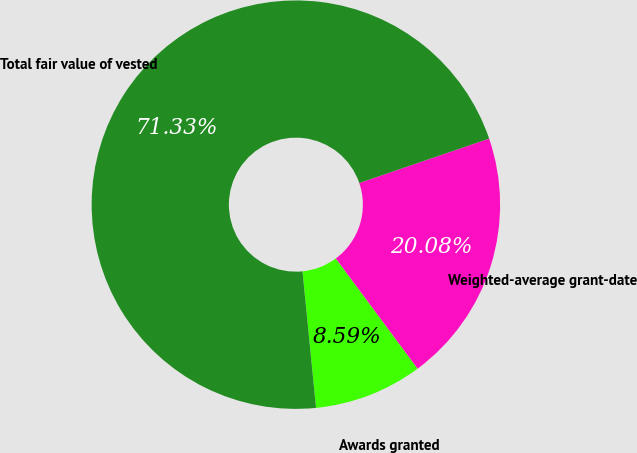Convert chart. <chart><loc_0><loc_0><loc_500><loc_500><pie_chart><fcel>Awards granted<fcel>Weighted-average grant-date<fcel>Total fair value of vested<nl><fcel>8.59%<fcel>20.08%<fcel>71.33%<nl></chart> 